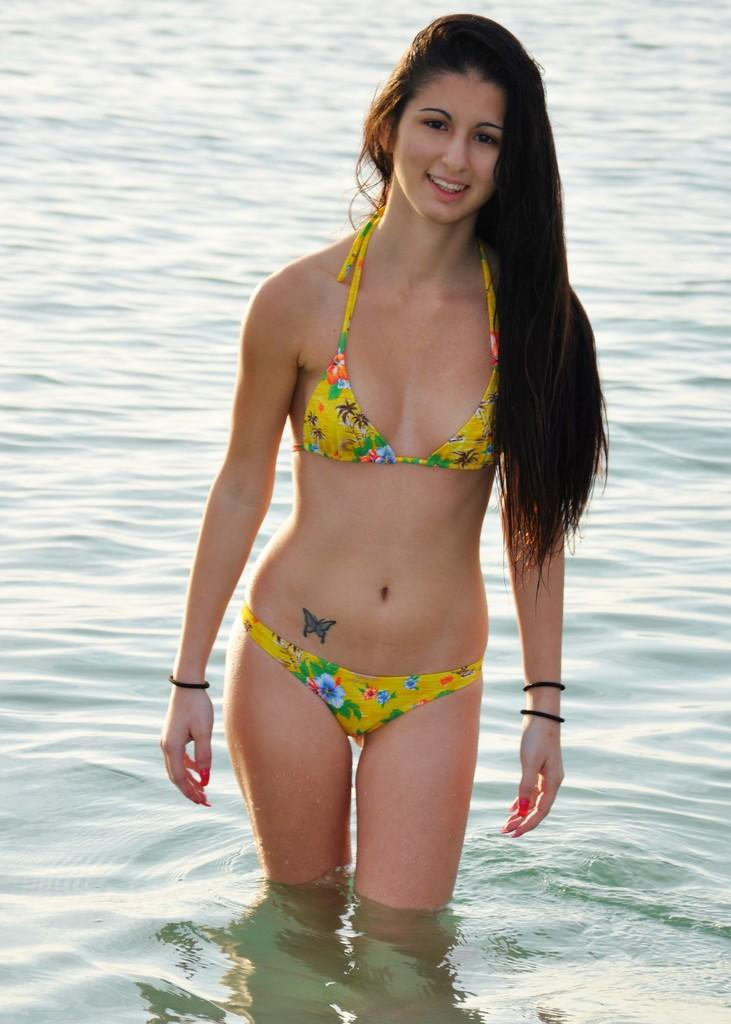Who is present in the image? There is a woman in the image. What is the woman doing in the image? The woman is in the water. What is the woman's expression in the image? The woman is smiling. What type of plough is the woman using in the image? There is no plough present in the image; the woman is in the water and not using any farming equipment. 